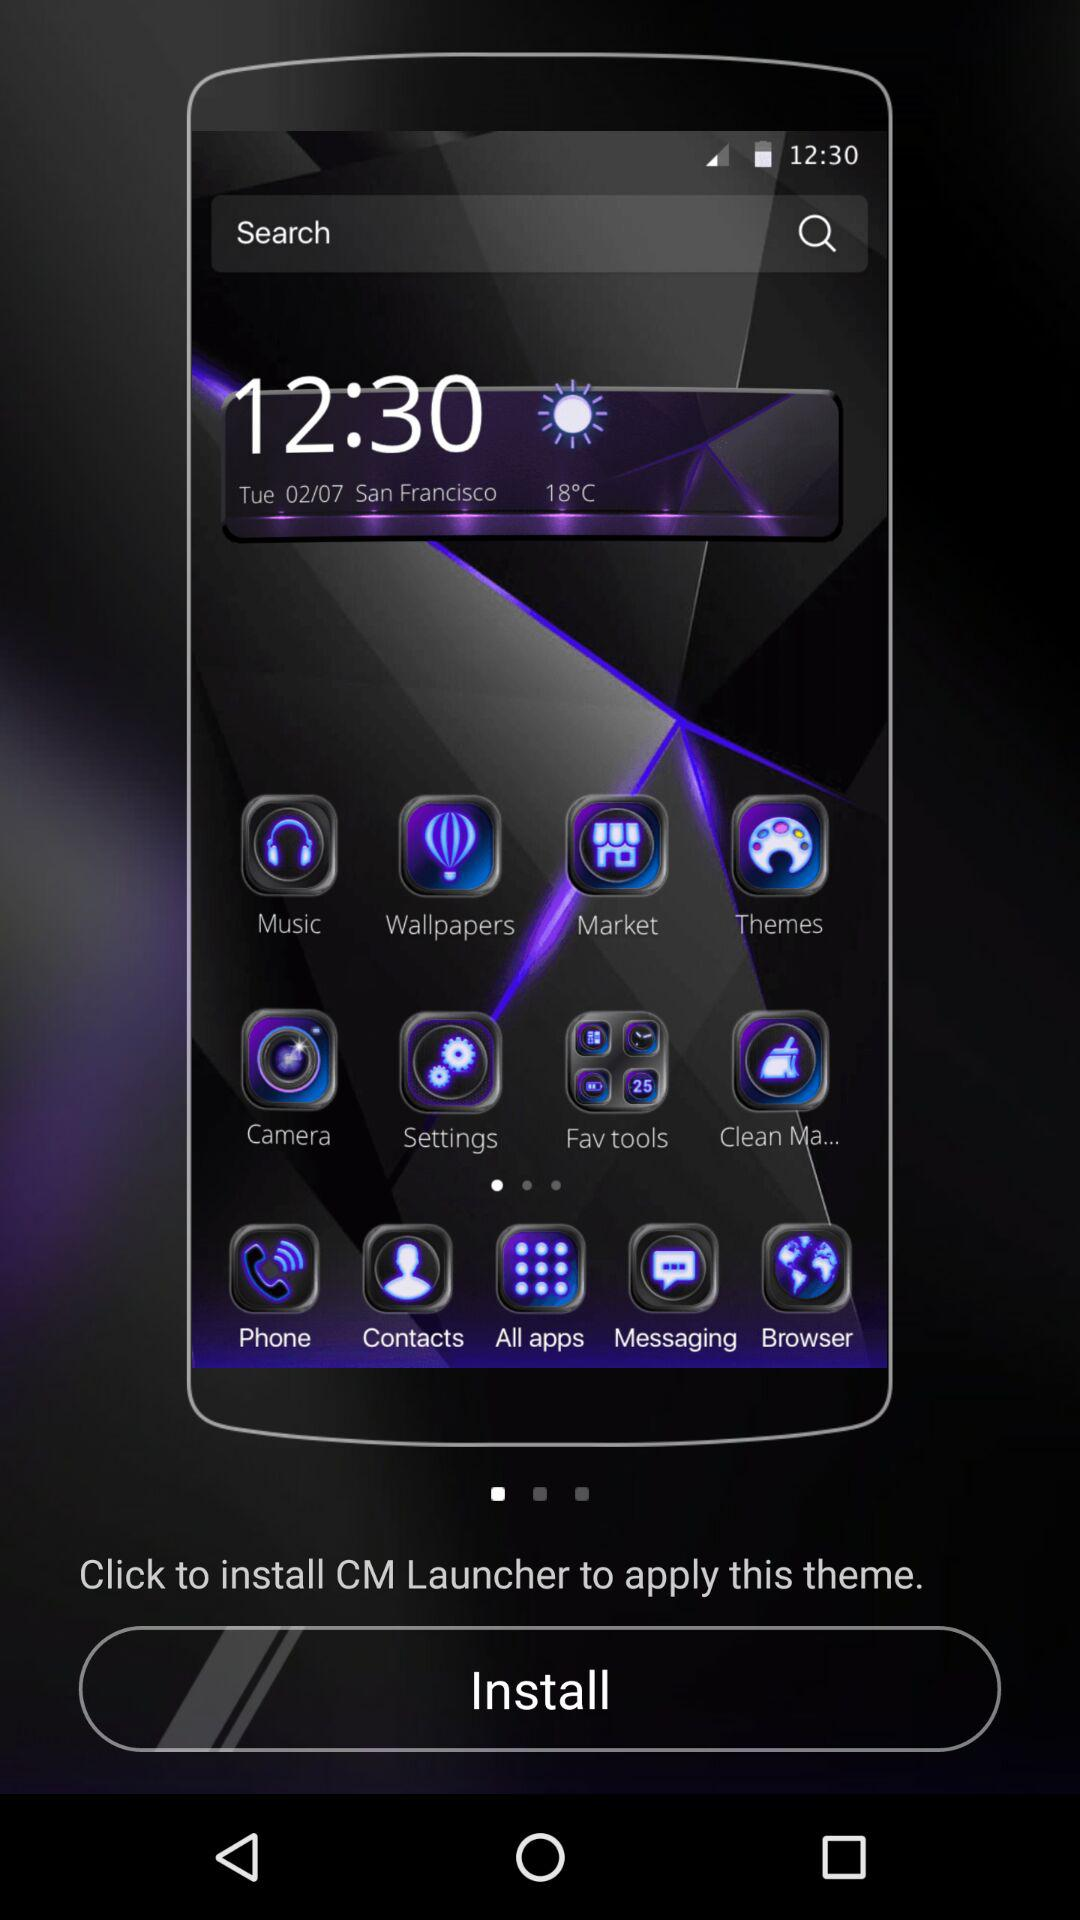How many applications can be installed with "CM Launcher"?
When the provided information is insufficient, respond with <no answer>. <no answer> 